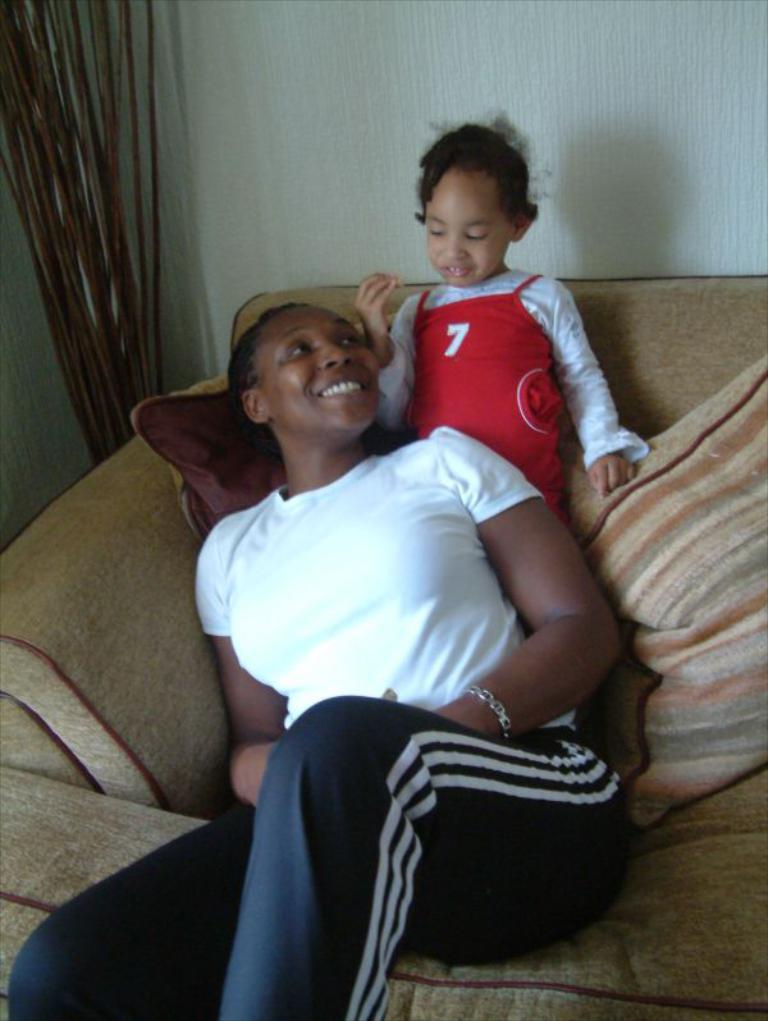What is the person in the image doing? The person is sitting on the couch in the image. Who else is present in the image? There is a child standing in the image. What can be seen on the couch besides the person? There are pillows in the image. What is visible in the background of the image? There is a wall visible in the image. What objects are made of wood in the image? There are wooden sticks in the image. What type of airplane is the spy using to fly over the story in the image? There is no airplane, spy, or story present in the image; it only features a person sitting on a couch, a child standing, pillows, a wall, and wooden sticks. 